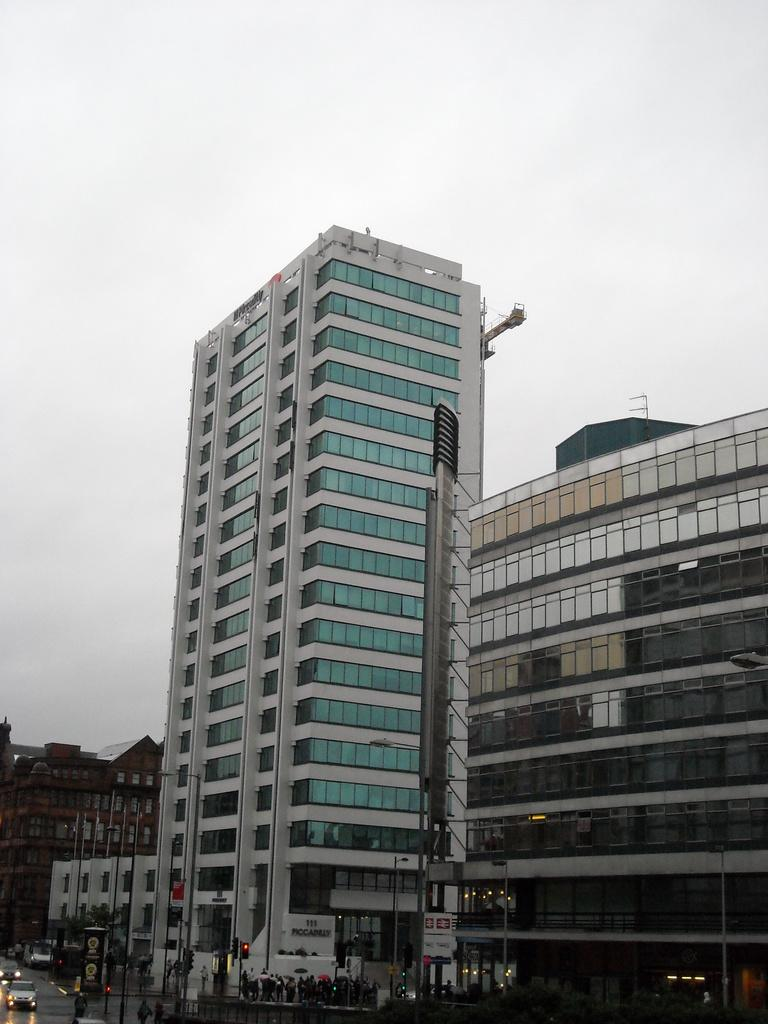What structures can be seen in the image? There are poles in the image. What else is present in the image besides poles? There are vehicles and people in the image. What can be seen in the background of the image? There are buildings and the sky visible in the background of the image. What type of celery is being used to fix the heat in the image? There is no celery present in the image, and no indication of heat or a need for fixing it. 